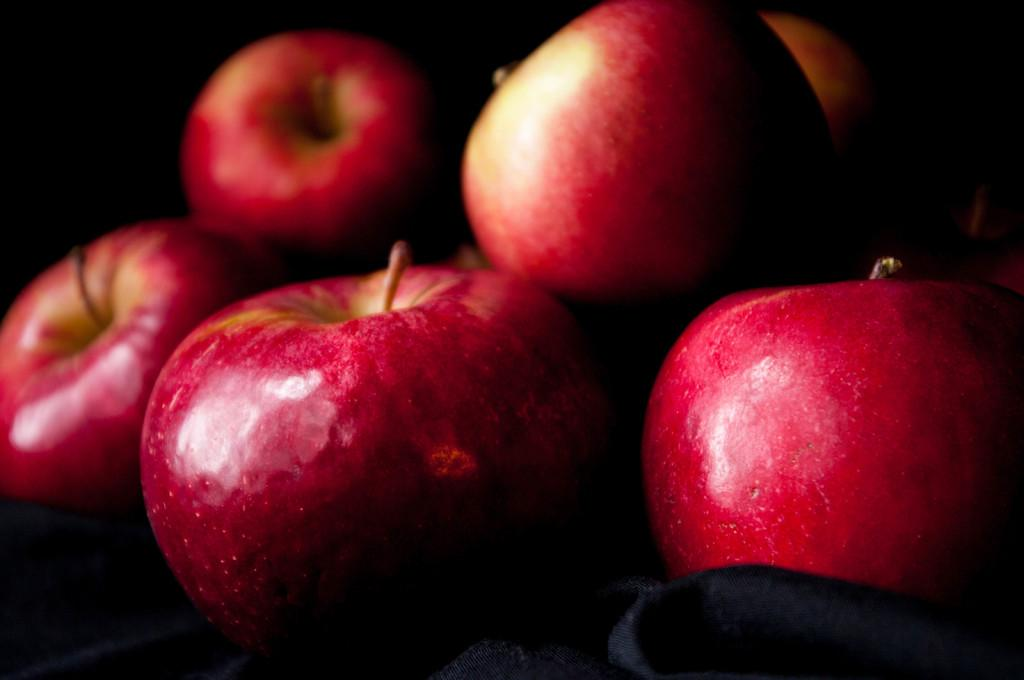What type of fruit is present in the image? There are apples in the image. Can you describe the background of the apples? The background of the apples is dark. What mathematical division is being performed on the apples in the image? There is no mathematical division being performed on the apples in the image; they are simply present. What scientific theory is being demonstrated with the apples in the image? There is no scientific theory being demonstrated with the apples in the image; they are simply present. 